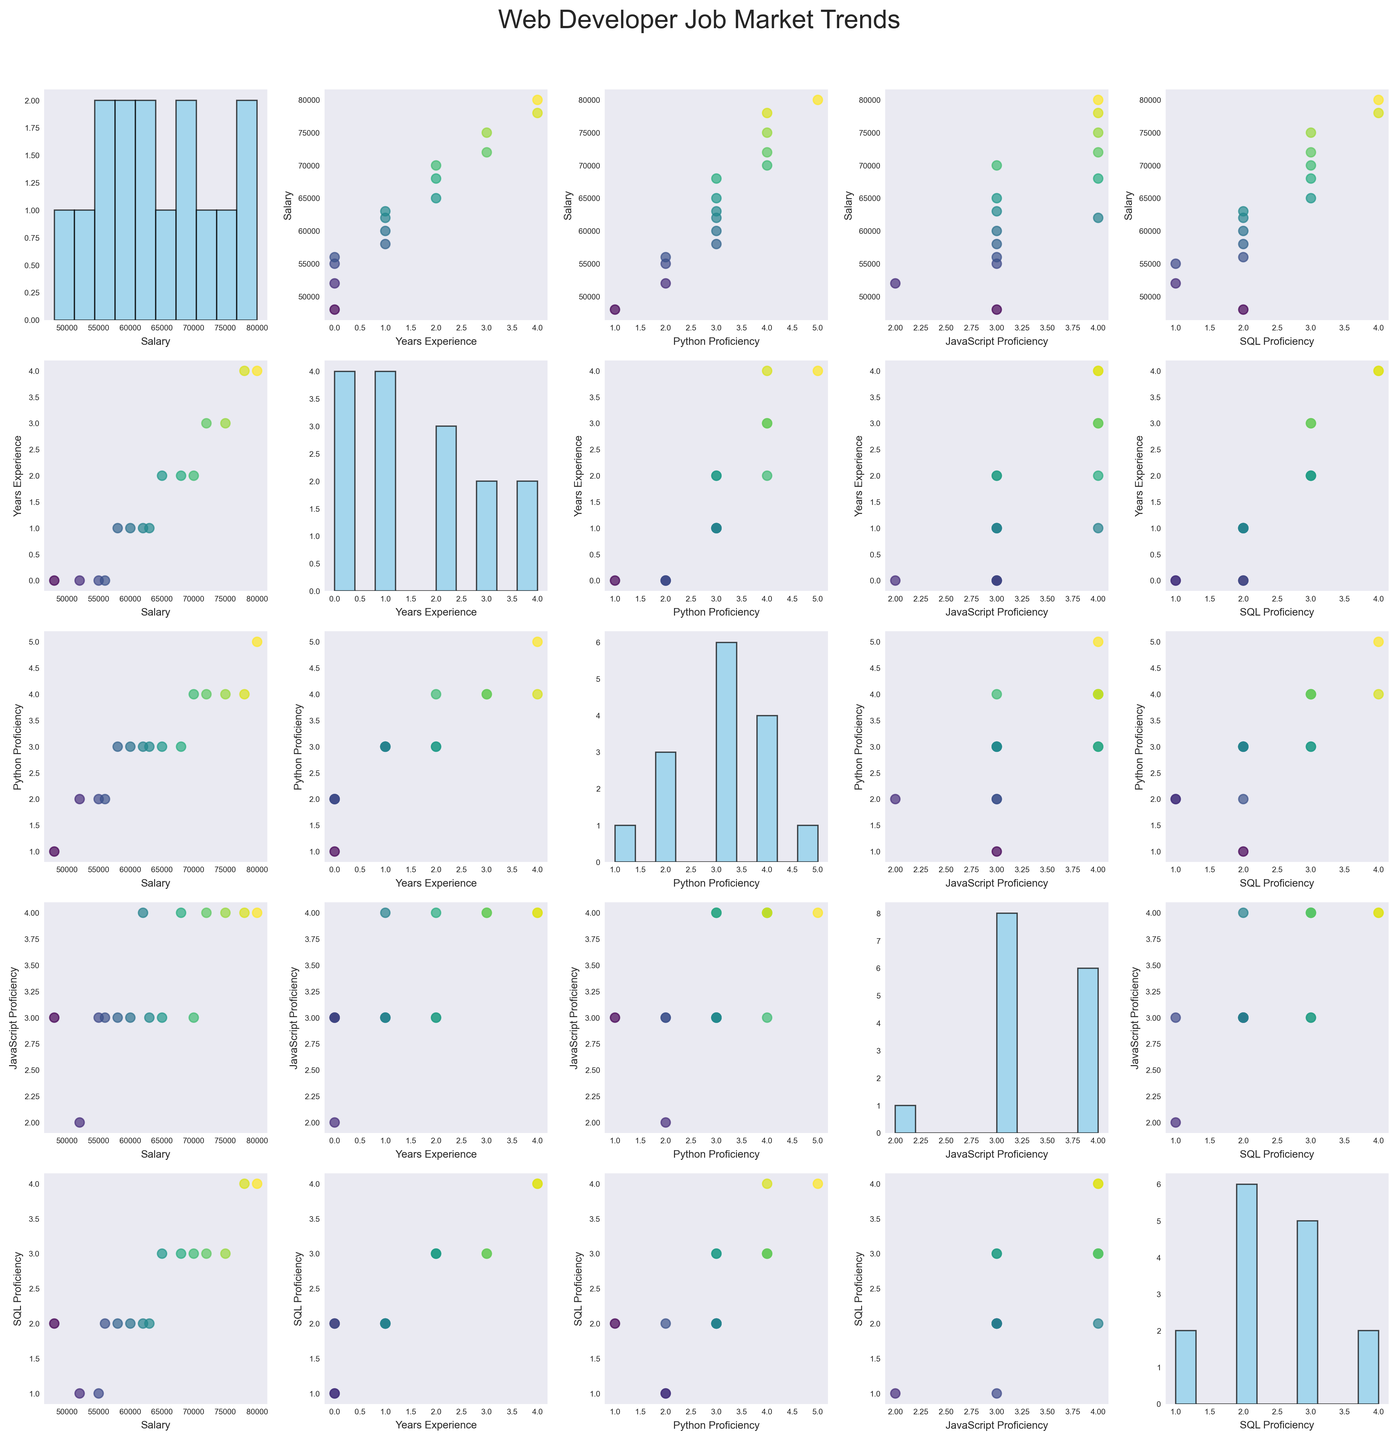What's the title of the figure? The title of the figure is placed at the top center of the plot. It summarizes the content being depicted. In this case, the title reads "Web Developer Job Market Trends"
Answer: Web Developer Job Market Trends How many variables are being compared in the scatterplot matrix? To determine the number of variables, you count the number of columns or rows in the matrix since each variable is represented as both a row and a column. There are 5 variables.
Answer: 5 What color represents the salary values in the scatterplots? The scatterplots use a colormap to represent the salary values, where colors range along a gradient that typically runs from blue to yellow-green. The exact colors present a blend between these shades.
Answer: Blue to yellow-green gradient What is the general trend between Years of Experience and Salary? Looking at the scatterplot where "Years_Experience" is on the x-axis and "Salary" is on the y-axis, there's a visible upward trend. As the years of experience increase, the salary generally increases as well.
Answer: Positive correlation How is the distribution of JavaScript Proficiency across different job offers? For this, you look at the histogram plotted along the diagonal where the "JavaScript_Proficiency" variable is both the x-axis and y-axis. The bars of the histogram show the frequency of different levels of proficiency with peaks indicating common proficiency levels.
Answer: Various, with common peaks around 3 and 4 Which location has the highest salary, and what is that salary? Observing the scatterplot matrix and identifying the outliers in the scatterplots involving salary can help identify highest data points. One particularly high salary data point occurs in the location labeled "Washington DC."
Answer: Washington DC, $80000 Are there any anomalies or outliers visible in the relationship between SQL Proficiency and Salary? By examining the scatterplot where "SQL_Proficiency" is on the x-axis and "Salary" on the y-axis, one can see if any points distinctly deviate from the general trend. There is one or more noticeable outlier(s) which could be considered abnormal given the rest of the data distribution.
Answer: Yes, there are outliers Do developers with Python Proficiency of 4 generally have higher salaries compared to those with Python Proficiency of 2? You need to cross-examine the scatter plots where "Python_Proficiency" is on the x-axis and "Salary" on the y-axis, and then compare the cluster of data points corresponding to the proficiency levels of 4 and 2. Salaries for proficiency of 4 are generally higher.
Answer: Yes What is the common range of Years of Experience for developers earning above $70,000? To answer this, you look at the scatter plots involving "Salary" and identify points where Salary is above $70,000, then check the corresponding "Years_Experience" values. Most developers earning above $70,000 have 2, 3, or 4 years of experience.
Answer: 2 to 4 years What patterns do you see between Python Proficiency and JavaScript Proficiency? By examining the scatterplot where "Python_Proficiency" is on the y-axis and "JavaScript_Proficiency" is on the x-axis, one can notice any trends. There is a visible pattern where higher proficiency in one language correlates with higher proficiency in the other.
Answer: Positive correlation 